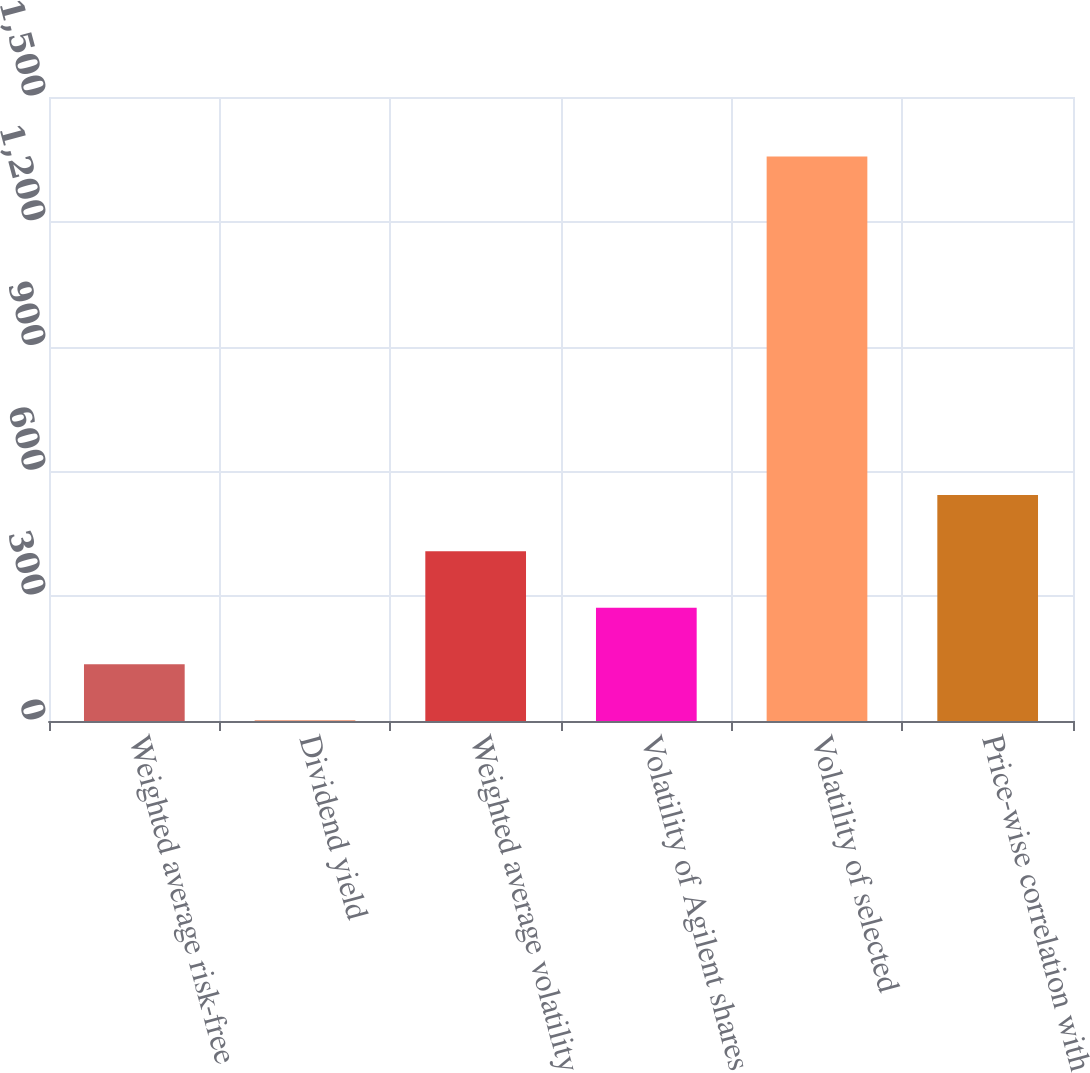Convert chart to OTSL. <chart><loc_0><loc_0><loc_500><loc_500><bar_chart><fcel>Weighted average risk-free<fcel>Dividend yield<fcel>Weighted average volatility<fcel>Volatility of Agilent shares<fcel>Volatility of selected<fcel>Price-wise correlation with<nl><fcel>136.6<fcel>1<fcel>407.8<fcel>272.2<fcel>1357<fcel>543.4<nl></chart> 